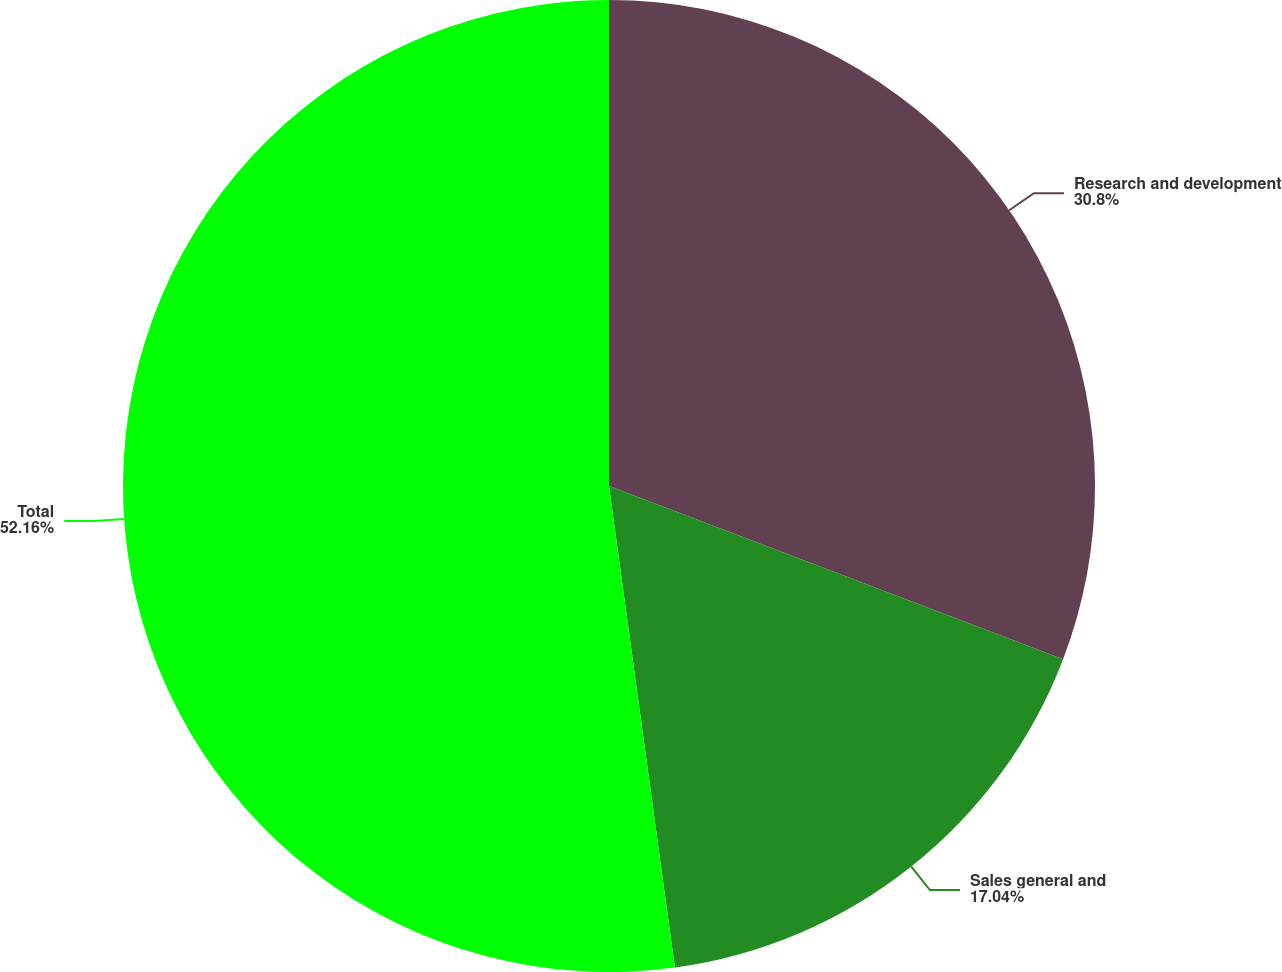Convert chart to OTSL. <chart><loc_0><loc_0><loc_500><loc_500><pie_chart><fcel>Research and development<fcel>Sales general and<fcel>Total<nl><fcel>30.8%<fcel>17.04%<fcel>52.17%<nl></chart> 